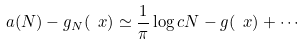<formula> <loc_0><loc_0><loc_500><loc_500>a ( N ) - g _ { N } ( \ x ) \simeq \frac { 1 } { \pi } \log c N - g ( \ x ) + \cdots</formula> 